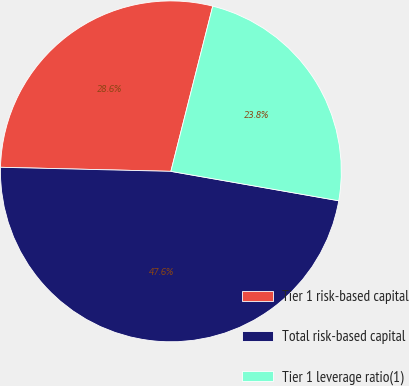<chart> <loc_0><loc_0><loc_500><loc_500><pie_chart><fcel>Tier 1 risk-based capital<fcel>Total risk-based capital<fcel>Tier 1 leverage ratio(1)<nl><fcel>28.57%<fcel>47.62%<fcel>23.81%<nl></chart> 